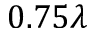Convert formula to latex. <formula><loc_0><loc_0><loc_500><loc_500>0 . 7 5 \lambda</formula> 